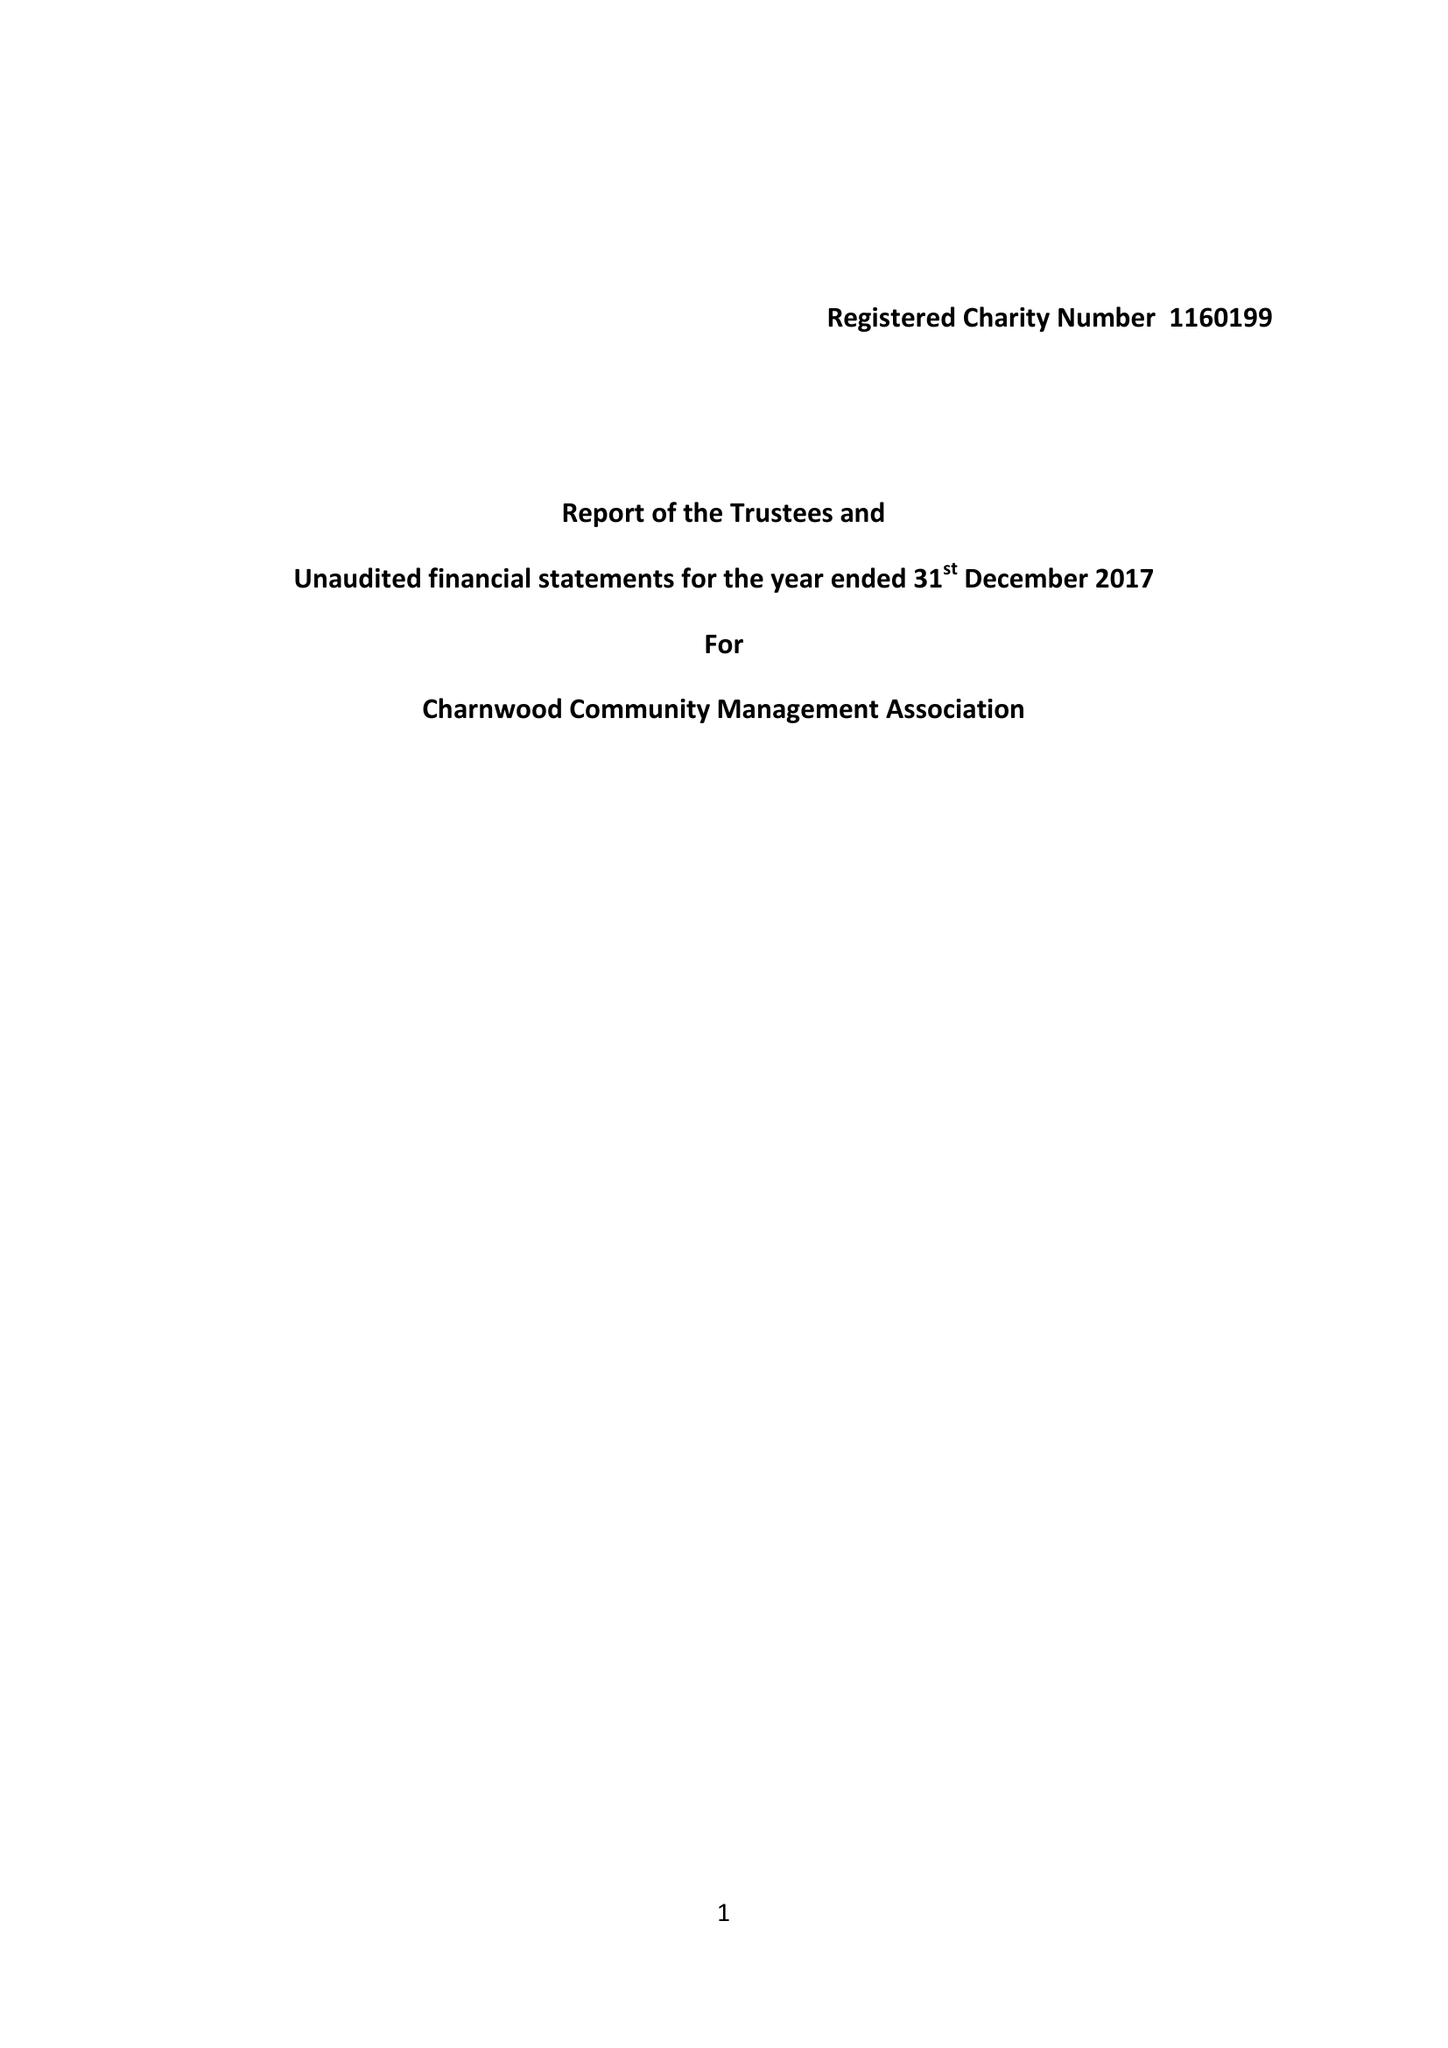What is the value for the address__post_town?
Answer the question using a single word or phrase. HITCHIN 